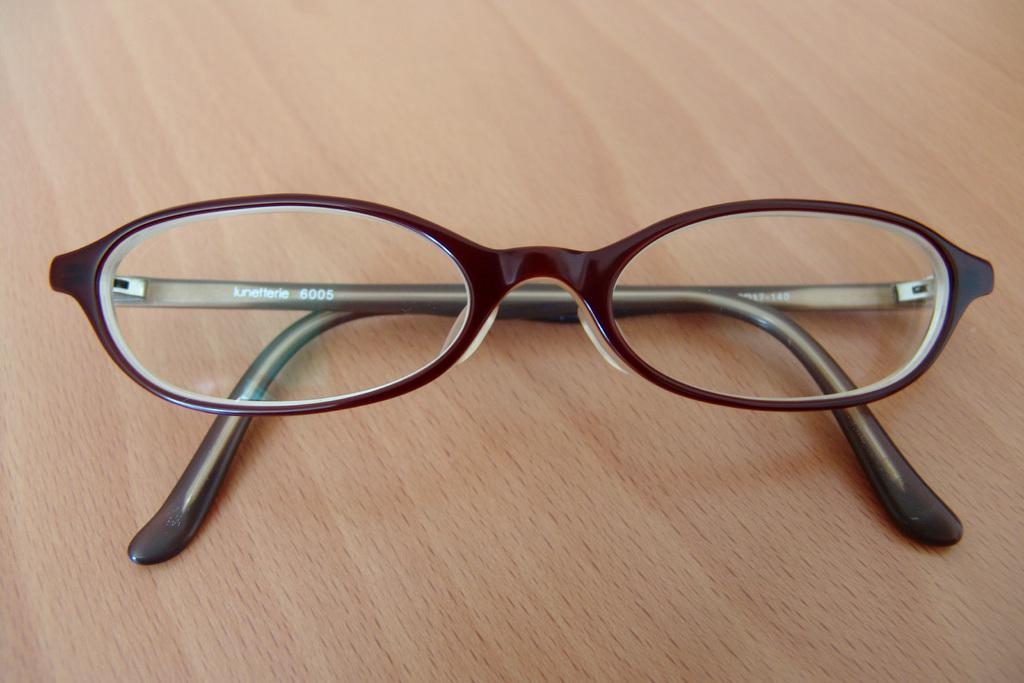What object is present in the image that is commonly used for vision correction? There are spectacles in the image. How are the spectacles positioned in the image? The spectacles are folded. Where are the spectacles located in the image? The spectacles are placed on a table. How many dolls are playing with the spectacles in the image? There are no dolls present in the image, and the spectacles are not being played with. 